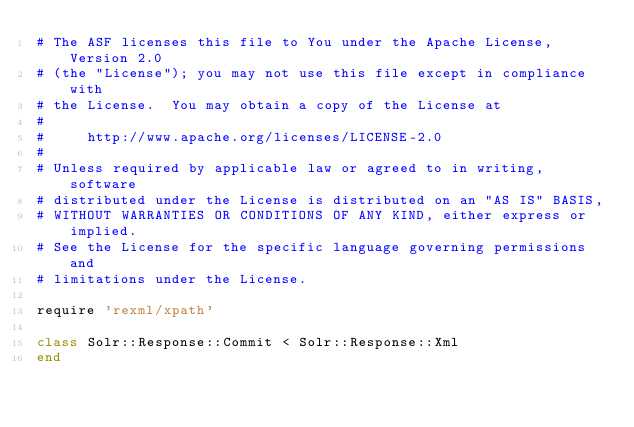<code> <loc_0><loc_0><loc_500><loc_500><_Ruby_># The ASF licenses this file to You under the Apache License, Version 2.0
# (the "License"); you may not use this file except in compliance with
# the License.  You may obtain a copy of the License at
#
#     http://www.apache.org/licenses/LICENSE-2.0
#
# Unless required by applicable law or agreed to in writing, software
# distributed under the License is distributed on an "AS IS" BASIS,
# WITHOUT WARRANTIES OR CONDITIONS OF ANY KIND, either express or implied.
# See the License for the specific language governing permissions and
# limitations under the License.

require 'rexml/xpath'

class Solr::Response::Commit < Solr::Response::Xml
end

</code> 